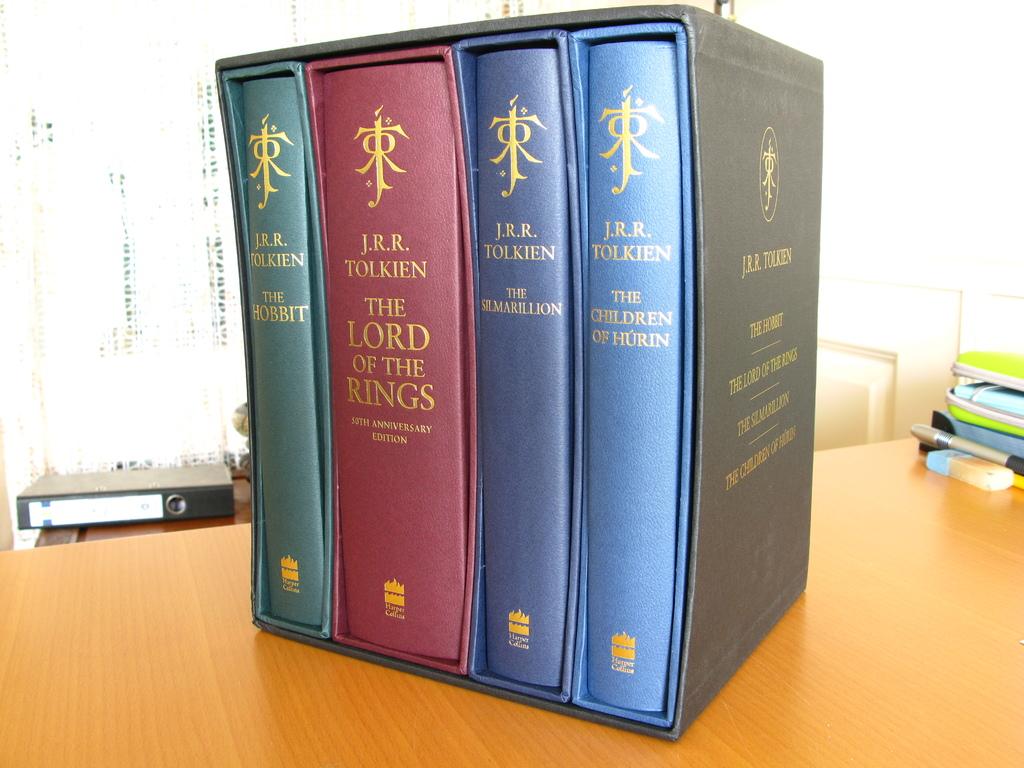Is this "lord of the ring" chines version?
Make the answer very short. Unanswerable. 